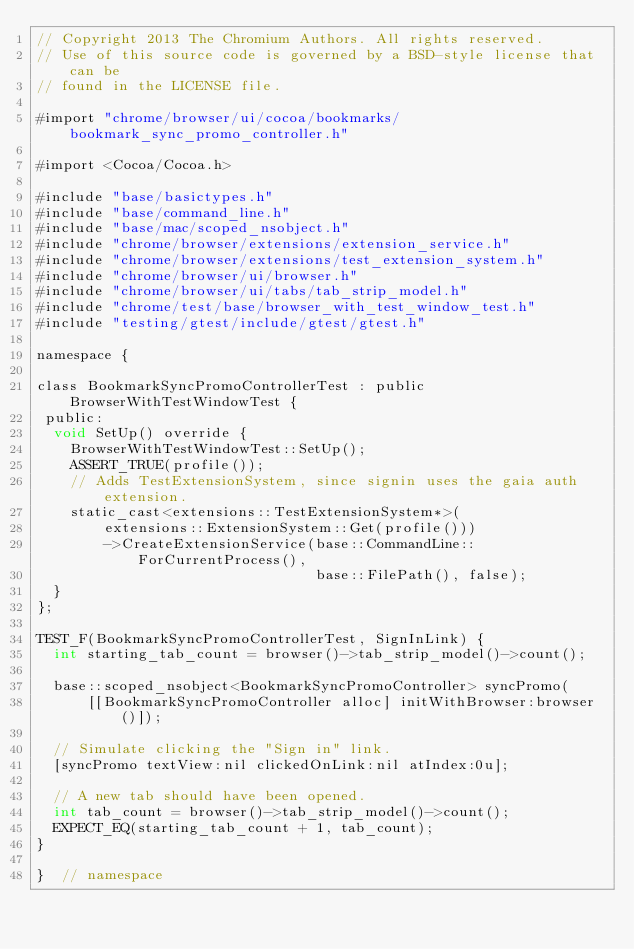<code> <loc_0><loc_0><loc_500><loc_500><_ObjectiveC_>// Copyright 2013 The Chromium Authors. All rights reserved.
// Use of this source code is governed by a BSD-style license that can be
// found in the LICENSE file.

#import "chrome/browser/ui/cocoa/bookmarks/bookmark_sync_promo_controller.h"

#import <Cocoa/Cocoa.h>

#include "base/basictypes.h"
#include "base/command_line.h"
#include "base/mac/scoped_nsobject.h"
#include "chrome/browser/extensions/extension_service.h"
#include "chrome/browser/extensions/test_extension_system.h"
#include "chrome/browser/ui/browser.h"
#include "chrome/browser/ui/tabs/tab_strip_model.h"
#include "chrome/test/base/browser_with_test_window_test.h"
#include "testing/gtest/include/gtest/gtest.h"

namespace {

class BookmarkSyncPromoControllerTest : public BrowserWithTestWindowTest {
 public:
  void SetUp() override {
    BrowserWithTestWindowTest::SetUp();
    ASSERT_TRUE(profile());
    // Adds TestExtensionSystem, since signin uses the gaia auth extension.
    static_cast<extensions::TestExtensionSystem*>(
        extensions::ExtensionSystem::Get(profile()))
        ->CreateExtensionService(base::CommandLine::ForCurrentProcess(),
                                 base::FilePath(), false);
  }
};

TEST_F(BookmarkSyncPromoControllerTest, SignInLink) {
  int starting_tab_count = browser()->tab_strip_model()->count();

  base::scoped_nsobject<BookmarkSyncPromoController> syncPromo(
      [[BookmarkSyncPromoController alloc] initWithBrowser:browser()]);

  // Simulate clicking the "Sign in" link.
  [syncPromo textView:nil clickedOnLink:nil atIndex:0u];

  // A new tab should have been opened.
  int tab_count = browser()->tab_strip_model()->count();
  EXPECT_EQ(starting_tab_count + 1, tab_count);
}

}  // namespace
</code> 